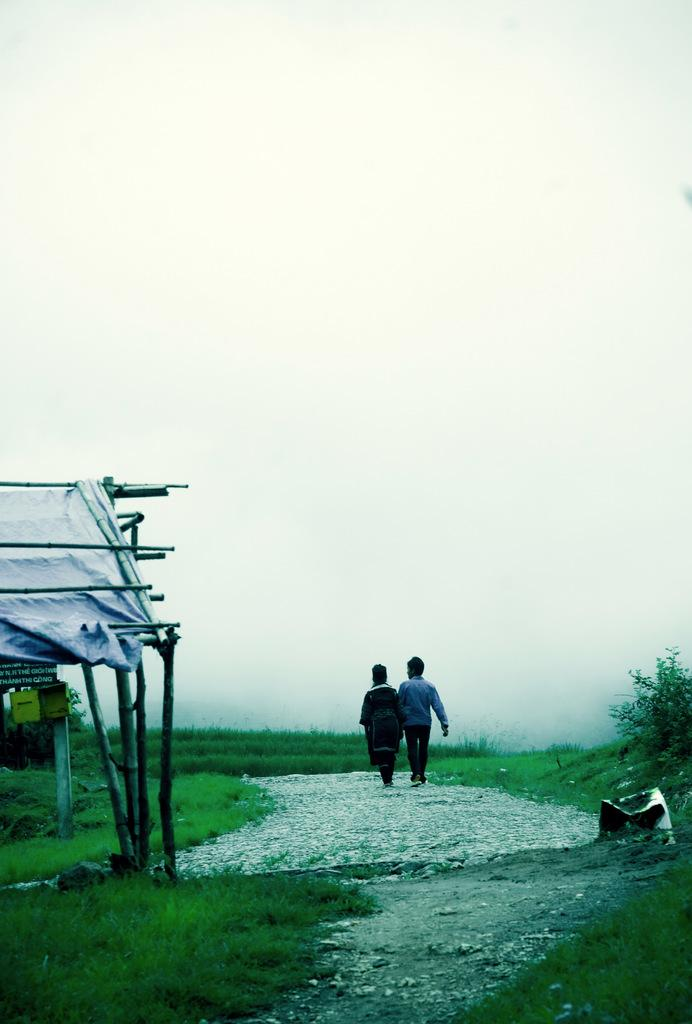What structure can be seen in the image? There is a shed in the image. What are the two persons in the image doing? The two persons are walking on the ground. Can you describe the object attached to the pillar? There is a box attached to a pillar. What type of vegetation is visible in the image? There is grass visible in the image. What else can be seen in the image besides the shed and the persons? There are trees in the image. What is visible in the background of the image? The sky is visible in the image. What type of gold coil is wrapped around the trees in the image? There is no gold coil present in the image; the trees are not wrapped in any coil. What type of flesh can be seen on the persons walking in the image? There is no mention of flesh or any body parts in the image; the focus is on the persons walking and the shed. 